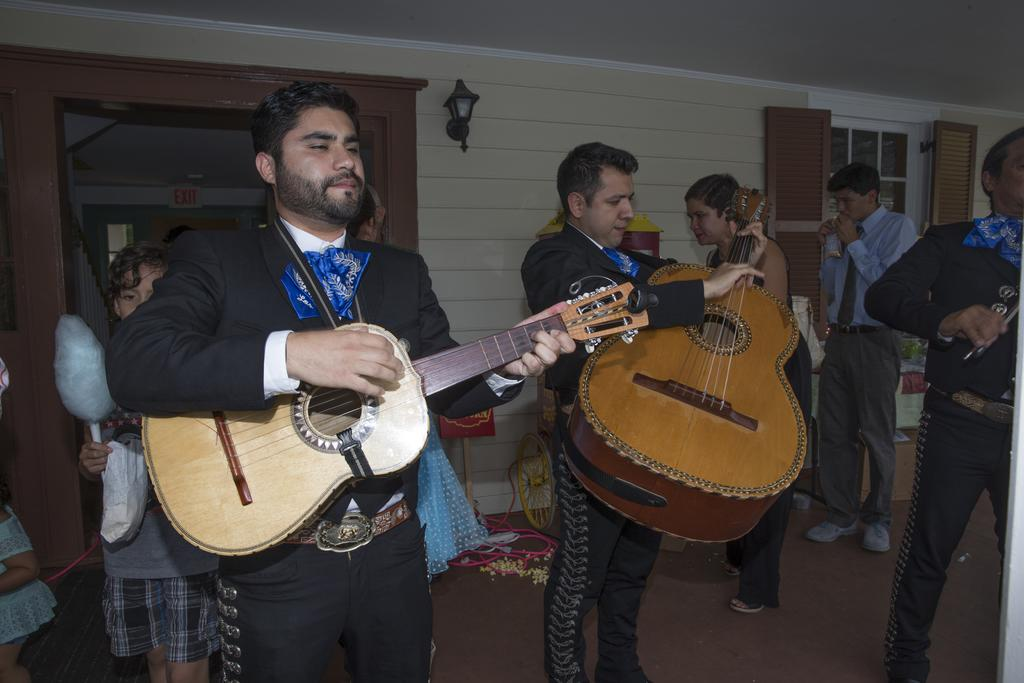How many people are in the image? There is a group of people in the image. What are two of the people doing in the image? Two men are playing guitar in the image. What can be seen in the background of the image? There is a wall and a light in the background of the image. What type of bear can be seen playing the guitar in the image? There is no bear present in the image; the two men playing guitar are human. 